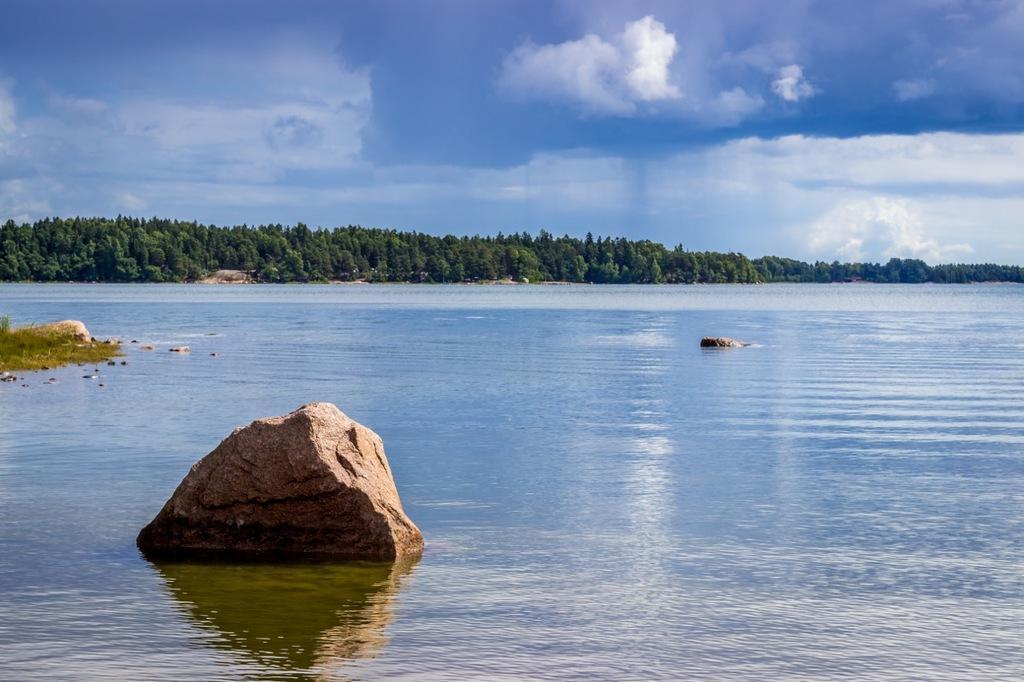Please provide a concise description of this image. In this image there is water. Also there are rocks. In the background there are trees. Also there is sky with clouds. 